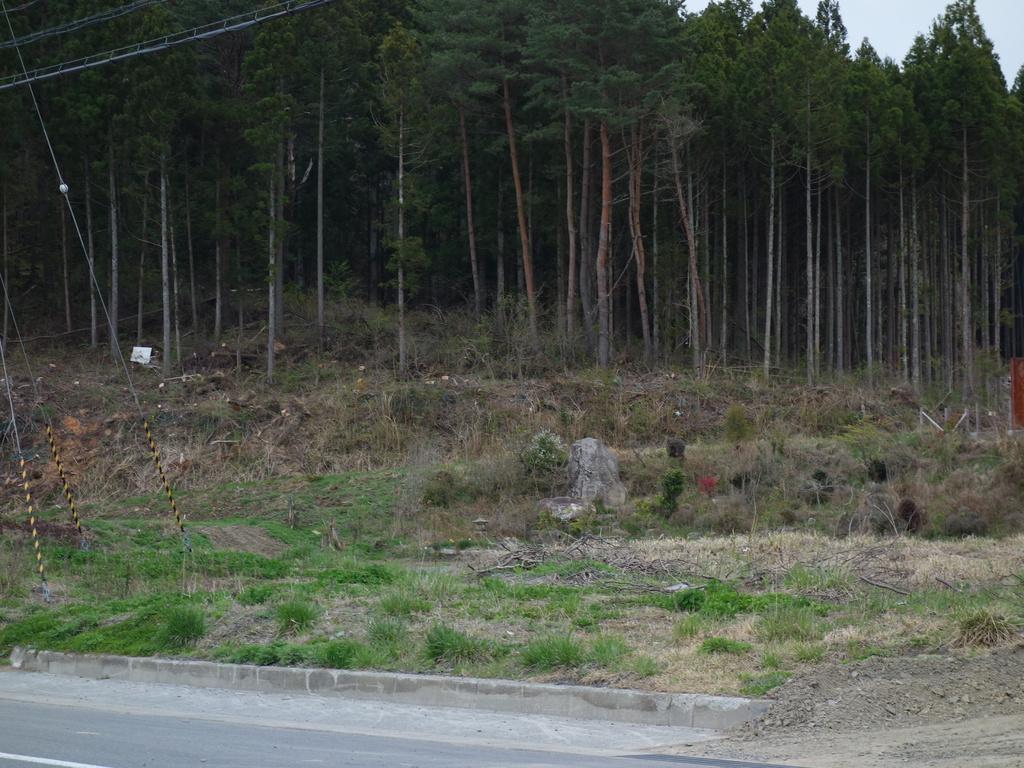Please provide a concise description of this image. In this image I can see grass and trees in green color. Background the sky is in white color. 